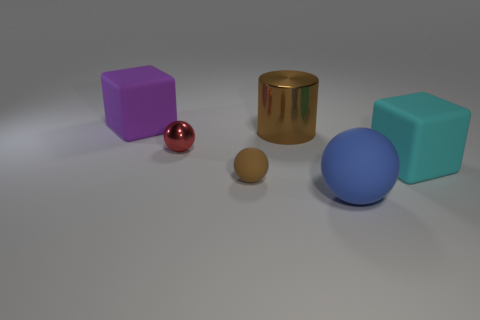Can you describe the shapes and colors of the objects in the image? Certainly! There are five objects in the image, each with its unique shape and color. From left to right: a purple cube, a small glossy red sphere, a matte brown cylinder, a matte brown smaller sphere, and a large matte blue sphere. 